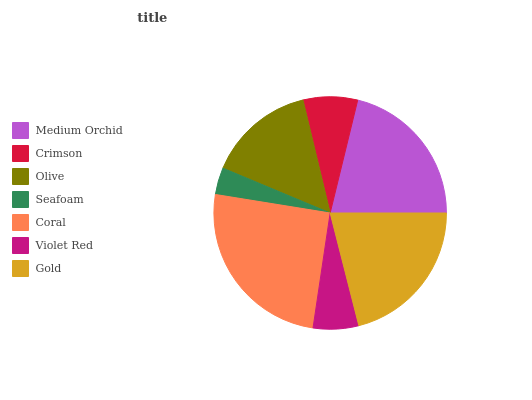Is Seafoam the minimum?
Answer yes or no. Yes. Is Coral the maximum?
Answer yes or no. Yes. Is Crimson the minimum?
Answer yes or no. No. Is Crimson the maximum?
Answer yes or no. No. Is Medium Orchid greater than Crimson?
Answer yes or no. Yes. Is Crimson less than Medium Orchid?
Answer yes or no. Yes. Is Crimson greater than Medium Orchid?
Answer yes or no. No. Is Medium Orchid less than Crimson?
Answer yes or no. No. Is Olive the high median?
Answer yes or no. Yes. Is Olive the low median?
Answer yes or no. Yes. Is Medium Orchid the high median?
Answer yes or no. No. Is Medium Orchid the low median?
Answer yes or no. No. 